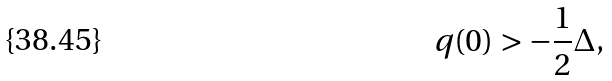Convert formula to latex. <formula><loc_0><loc_0><loc_500><loc_500>q ( 0 ) > - \frac { 1 } { 2 } \Delta ,</formula> 